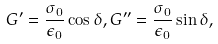Convert formula to latex. <formula><loc_0><loc_0><loc_500><loc_500>G ^ { \prime } = \frac { \sigma _ { 0 } } { \epsilon _ { 0 } } \cos \delta , G ^ { \prime \prime } = \frac { \sigma _ { 0 } } { \epsilon _ { 0 } } \sin \delta ,</formula> 